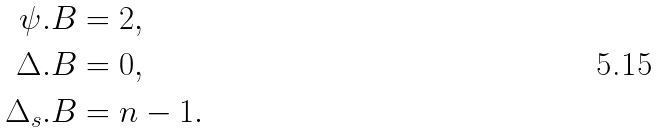Convert formula to latex. <formula><loc_0><loc_0><loc_500><loc_500>\psi . B & = 2 , \\ \Delta . B & = 0 , \\ \Delta _ { s } . B & = n - 1 .</formula> 